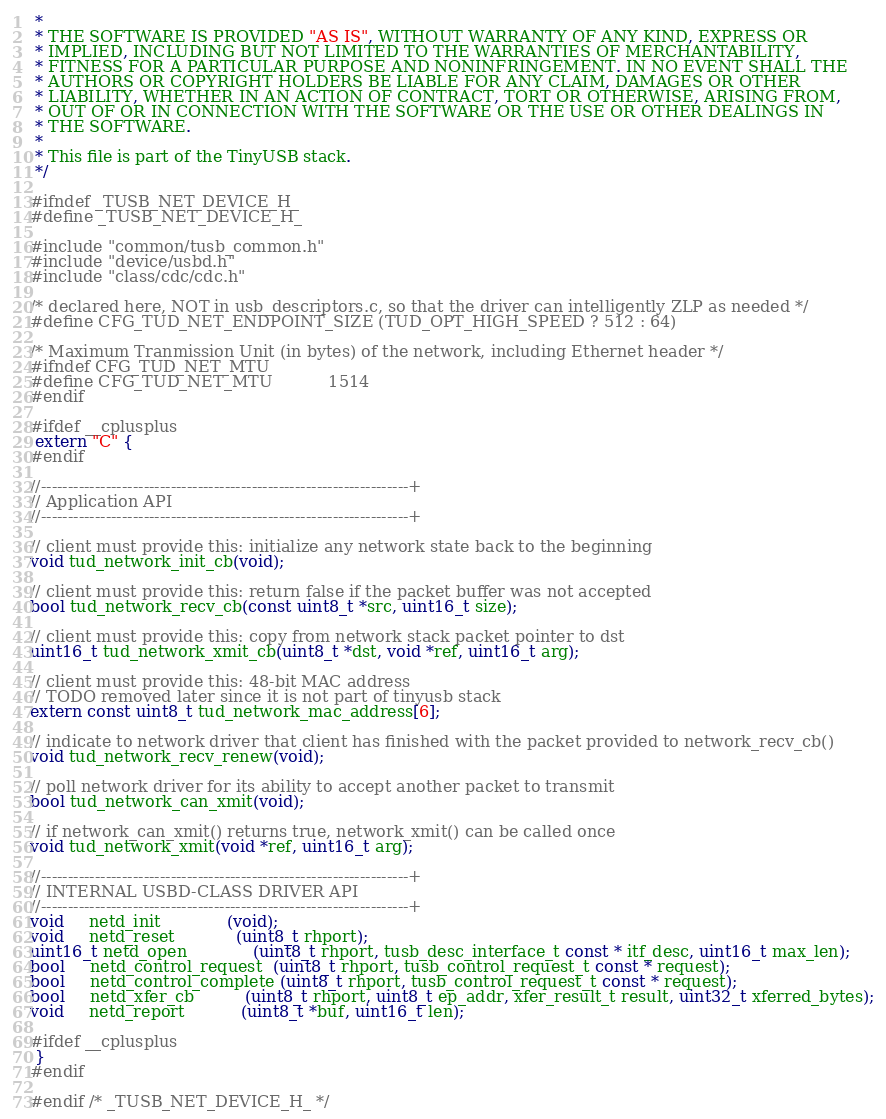<code> <loc_0><loc_0><loc_500><loc_500><_C_> *
 * THE SOFTWARE IS PROVIDED "AS IS", WITHOUT WARRANTY OF ANY KIND, EXPRESS OR
 * IMPLIED, INCLUDING BUT NOT LIMITED TO THE WARRANTIES OF MERCHANTABILITY,
 * FITNESS FOR A PARTICULAR PURPOSE AND NONINFRINGEMENT. IN NO EVENT SHALL THE
 * AUTHORS OR COPYRIGHT HOLDERS BE LIABLE FOR ANY CLAIM, DAMAGES OR OTHER
 * LIABILITY, WHETHER IN AN ACTION OF CONTRACT, TORT OR OTHERWISE, ARISING FROM,
 * OUT OF OR IN CONNECTION WITH THE SOFTWARE OR THE USE OR OTHER DEALINGS IN
 * THE SOFTWARE.
 *
 * This file is part of the TinyUSB stack.
 */

#ifndef _TUSB_NET_DEVICE_H_
#define _TUSB_NET_DEVICE_H_

#include "common/tusb_common.h"
#include "device/usbd.h"
#include "class/cdc/cdc.h"

/* declared here, NOT in usb_descriptors.c, so that the driver can intelligently ZLP as needed */
#define CFG_TUD_NET_ENDPOINT_SIZE (TUD_OPT_HIGH_SPEED ? 512 : 64)

/* Maximum Tranmission Unit (in bytes) of the network, including Ethernet header */
#ifndef CFG_TUD_NET_MTU
#define CFG_TUD_NET_MTU           1514
#endif

#ifdef __cplusplus
 extern "C" {
#endif

//--------------------------------------------------------------------+
// Application API
//--------------------------------------------------------------------+

// client must provide this: initialize any network state back to the beginning
void tud_network_init_cb(void);

// client must provide this: return false if the packet buffer was not accepted
bool tud_network_recv_cb(const uint8_t *src, uint16_t size);

// client must provide this: copy from network stack packet pointer to dst
uint16_t tud_network_xmit_cb(uint8_t *dst, void *ref, uint16_t arg);

// client must provide this: 48-bit MAC address
// TODO removed later since it is not part of tinyusb stack
extern const uint8_t tud_network_mac_address[6];

// indicate to network driver that client has finished with the packet provided to network_recv_cb()
void tud_network_recv_renew(void);

// poll network driver for its ability to accept another packet to transmit
bool tud_network_can_xmit(void);

// if network_can_xmit() returns true, network_xmit() can be called once
void tud_network_xmit(void *ref, uint16_t arg);

//--------------------------------------------------------------------+
// INTERNAL USBD-CLASS DRIVER API
//--------------------------------------------------------------------+
void     netd_init             (void);
void     netd_reset            (uint8_t rhport);
uint16_t netd_open             (uint8_t rhport, tusb_desc_interface_t const * itf_desc, uint16_t max_len);
bool     netd_control_request  (uint8_t rhport, tusb_control_request_t const * request);
bool     netd_control_complete (uint8_t rhport, tusb_control_request_t const * request);
bool     netd_xfer_cb          (uint8_t rhport, uint8_t ep_addr, xfer_result_t result, uint32_t xferred_bytes);
void     netd_report           (uint8_t *buf, uint16_t len);

#ifdef __cplusplus
 }
#endif

#endif /* _TUSB_NET_DEVICE_H_ */
</code> 